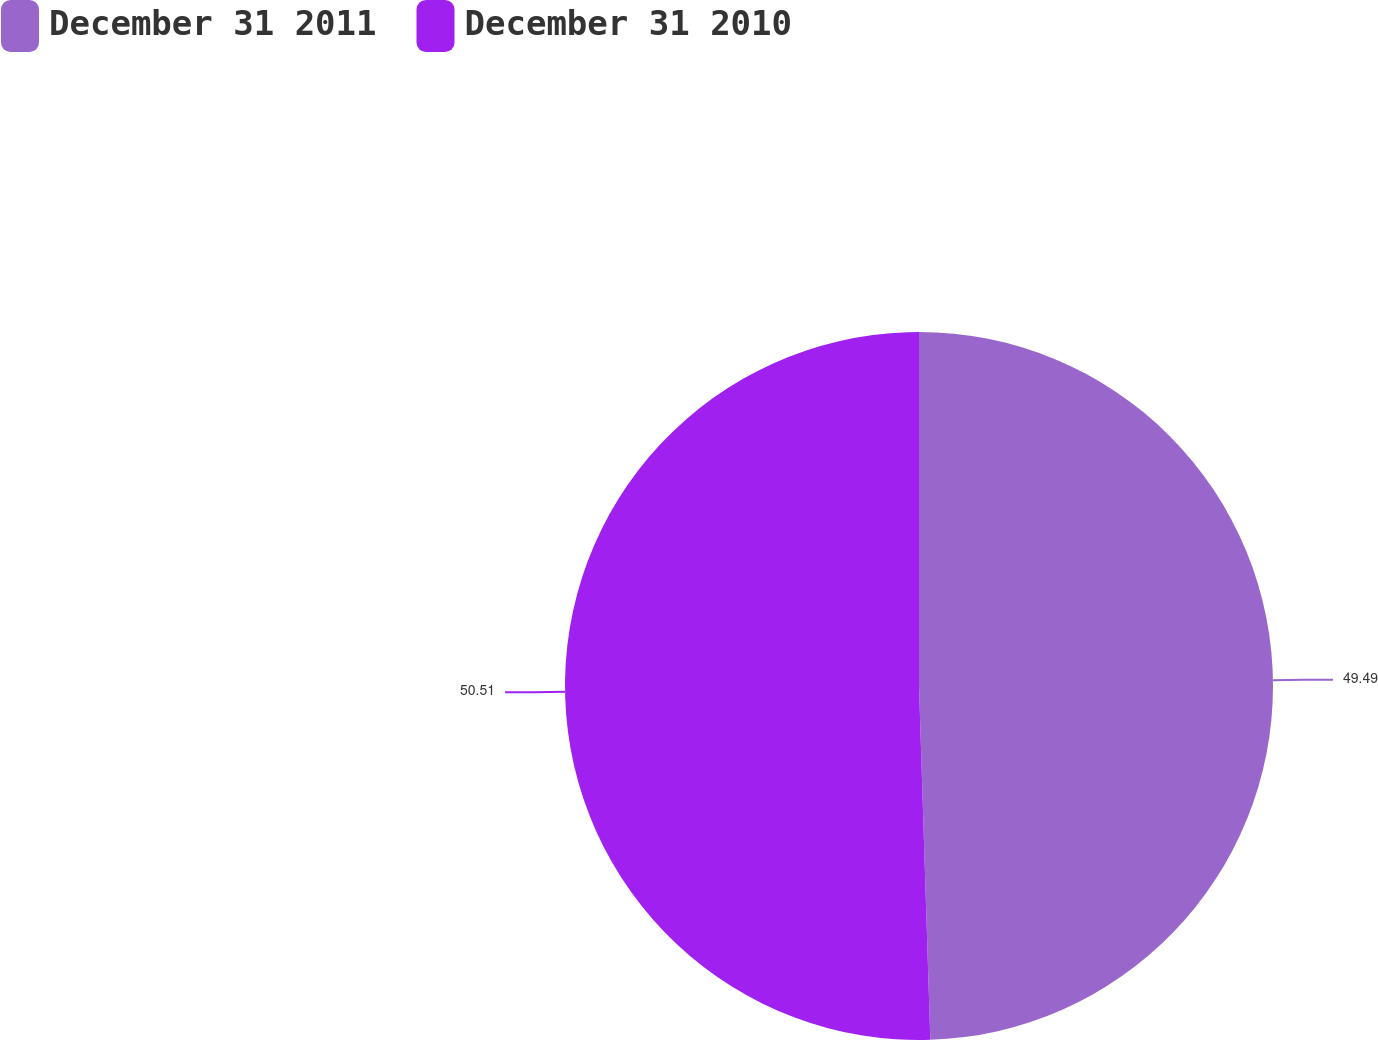Convert chart. <chart><loc_0><loc_0><loc_500><loc_500><pie_chart><fcel>December 31 2011<fcel>December 31 2010<nl><fcel>49.49%<fcel>50.51%<nl></chart> 